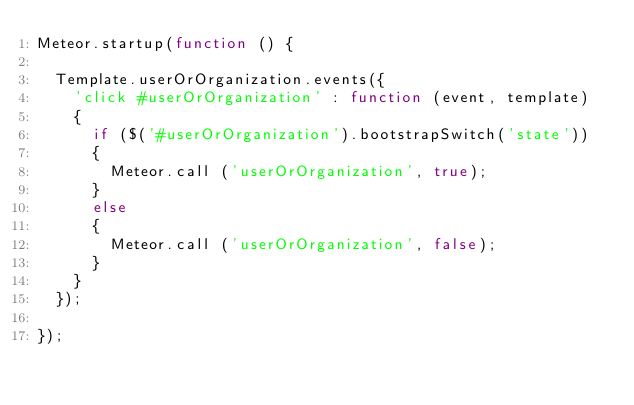<code> <loc_0><loc_0><loc_500><loc_500><_JavaScript_>Meteor.startup(function () {

  Template.userOrOrganization.events({
    'click #userOrOrganization' : function (event, template)
    {
    	if ($('#userOrOrganization').bootstrapSwitch('state'))
    	{
    		Meteor.call ('userOrOrganization', true);
    	}
    	else
    	{
    		Meteor.call ('userOrOrganization', false);
    	}
    }
  });

});
</code> 